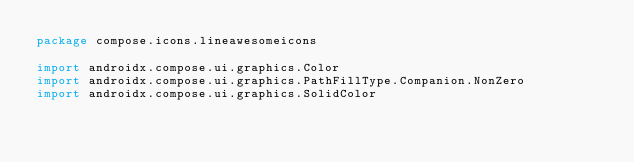<code> <loc_0><loc_0><loc_500><loc_500><_Kotlin_>package compose.icons.lineawesomeicons

import androidx.compose.ui.graphics.Color
import androidx.compose.ui.graphics.PathFillType.Companion.NonZero
import androidx.compose.ui.graphics.SolidColor</code> 